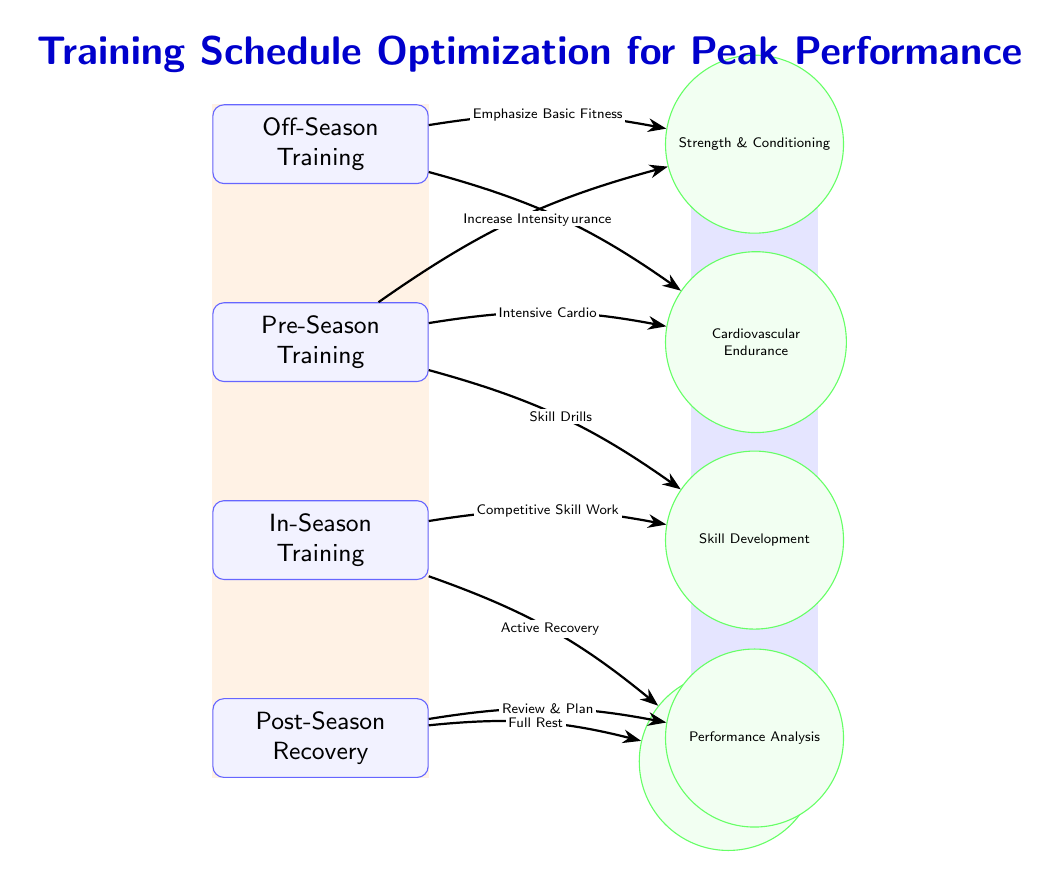What are the four main training phases shown in the diagram? The diagram lists four training phases: Off-Season Training, Pre-Season Training, In-Season Training, and Post-Season Recovery. These phases are represented as rectangles in the diagram.
Answer: Off-Season Training, Pre-Season Training, In-Season Training, Post-Season Recovery Which activity is associated with the Off-Season Training phase? In the diagram, the Off-Season Training phase has two arrows pointing to activities: Strength & Conditioning and Cardiovascular Endurance. These activities are placed to the right of the Off-Season Training node.
Answer: Strength & Conditioning, Cardiovascular Endurance What type of recovery is emphasized during In-Season Training? The diagram indicates that during the In-Season Training phase, the emphasis is on Active Recovery, which is depicted by the arrow leading from the In-Season Training node to the Rest & Recovery activity.
Answer: Active Recovery What are the two main focuses during Pre-Season Training? The diagram shows that Pre-Season Training focuses on increasing intensity in Strength & Conditioning, intensive cardio activities, and skill drills for Skill Development. There are three arrows emerging from the Pre-Season Training node, indicating these focuses.
Answer: Increase Intensity, Intensive Cardio, Skill Drills Which activity follows the Post-Season Recovery phase in the diagram? The diagram illustrates that after the Post-Season Recovery phase, the focus shifts to Performance Analysis, which is represented by an arrow connecting the Post-Season Recovery node to the Performance Analysis activity node.
Answer: Performance Analysis Explain the flow of activities starting from Off-Season Training to In-Season Training. The flow begins at Off-Season Training, which emphasizes Basic Fitness and builds endurance through two activities: Strength & Conditioning and Cardiovascular Endurance. This sets the foundation for Pre-Season Training, which increases intensity, includes intensive cardio, and skill drills for skill development. Finally, this leads into In-Season Training, where Competitive Skill Work becomes a focus.
Answer: The flow goes: Off-Season Training → Pre-Season Training → In-Season Training What action is recommended during the Post-Season Recovery phase? The diagram suggests two primary actions during the Post-Season Recovery phase: Full Rest related to the Rest & Recovery activity and a Review & Plan related to the Performance Analysis activity. These are illustrated by arrows leading from the Post-Season Recovery node.
Answer: Full Rest, Review & Plan 